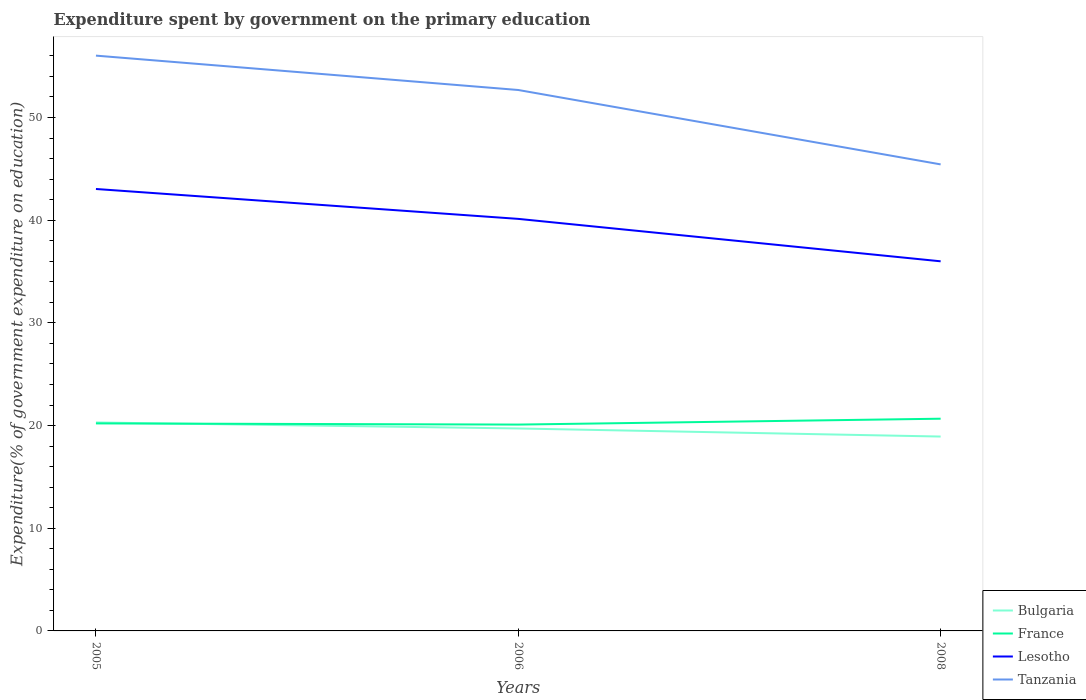Does the line corresponding to Lesotho intersect with the line corresponding to France?
Offer a terse response. No. Across all years, what is the maximum expenditure spent by government on the primary education in Tanzania?
Make the answer very short. 45.43. What is the total expenditure spent by government on the primary education in Lesotho in the graph?
Your answer should be very brief. 2.91. What is the difference between the highest and the second highest expenditure spent by government on the primary education in Tanzania?
Ensure brevity in your answer.  10.59. What is the difference between the highest and the lowest expenditure spent by government on the primary education in Tanzania?
Your response must be concise. 2. What is the difference between two consecutive major ticks on the Y-axis?
Keep it short and to the point. 10. Does the graph contain any zero values?
Provide a short and direct response. No. How many legend labels are there?
Offer a terse response. 4. What is the title of the graph?
Give a very brief answer. Expenditure spent by government on the primary education. Does "Japan" appear as one of the legend labels in the graph?
Your answer should be very brief. No. What is the label or title of the Y-axis?
Provide a succinct answer. Expenditure(% of government expenditure on education). What is the Expenditure(% of government expenditure on education) of Bulgaria in 2005?
Your answer should be very brief. 20.3. What is the Expenditure(% of government expenditure on education) of France in 2005?
Offer a very short reply. 20.21. What is the Expenditure(% of government expenditure on education) of Lesotho in 2005?
Make the answer very short. 43.04. What is the Expenditure(% of government expenditure on education) of Tanzania in 2005?
Make the answer very short. 56.02. What is the Expenditure(% of government expenditure on education) of Bulgaria in 2006?
Ensure brevity in your answer.  19.72. What is the Expenditure(% of government expenditure on education) in France in 2006?
Ensure brevity in your answer.  20.09. What is the Expenditure(% of government expenditure on education) in Lesotho in 2006?
Offer a very short reply. 40.12. What is the Expenditure(% of government expenditure on education) of Tanzania in 2006?
Your answer should be very brief. 52.68. What is the Expenditure(% of government expenditure on education) of Bulgaria in 2008?
Offer a very short reply. 18.93. What is the Expenditure(% of government expenditure on education) of France in 2008?
Give a very brief answer. 20.67. What is the Expenditure(% of government expenditure on education) of Lesotho in 2008?
Your answer should be compact. 35.99. What is the Expenditure(% of government expenditure on education) in Tanzania in 2008?
Your answer should be very brief. 45.43. Across all years, what is the maximum Expenditure(% of government expenditure on education) of Bulgaria?
Offer a very short reply. 20.3. Across all years, what is the maximum Expenditure(% of government expenditure on education) in France?
Offer a terse response. 20.67. Across all years, what is the maximum Expenditure(% of government expenditure on education) in Lesotho?
Your answer should be compact. 43.04. Across all years, what is the maximum Expenditure(% of government expenditure on education) of Tanzania?
Offer a very short reply. 56.02. Across all years, what is the minimum Expenditure(% of government expenditure on education) in Bulgaria?
Offer a very short reply. 18.93. Across all years, what is the minimum Expenditure(% of government expenditure on education) of France?
Your response must be concise. 20.09. Across all years, what is the minimum Expenditure(% of government expenditure on education) of Lesotho?
Give a very brief answer. 35.99. Across all years, what is the minimum Expenditure(% of government expenditure on education) in Tanzania?
Ensure brevity in your answer.  45.43. What is the total Expenditure(% of government expenditure on education) of Bulgaria in the graph?
Ensure brevity in your answer.  58.94. What is the total Expenditure(% of government expenditure on education) in France in the graph?
Provide a succinct answer. 60.97. What is the total Expenditure(% of government expenditure on education) in Lesotho in the graph?
Your response must be concise. 119.16. What is the total Expenditure(% of government expenditure on education) of Tanzania in the graph?
Provide a short and direct response. 154.13. What is the difference between the Expenditure(% of government expenditure on education) of Bulgaria in 2005 and that in 2006?
Give a very brief answer. 0.58. What is the difference between the Expenditure(% of government expenditure on education) of France in 2005 and that in 2006?
Provide a short and direct response. 0.11. What is the difference between the Expenditure(% of government expenditure on education) in Lesotho in 2005 and that in 2006?
Make the answer very short. 2.91. What is the difference between the Expenditure(% of government expenditure on education) of Tanzania in 2005 and that in 2006?
Provide a succinct answer. 3.35. What is the difference between the Expenditure(% of government expenditure on education) in Bulgaria in 2005 and that in 2008?
Give a very brief answer. 1.37. What is the difference between the Expenditure(% of government expenditure on education) in France in 2005 and that in 2008?
Provide a short and direct response. -0.46. What is the difference between the Expenditure(% of government expenditure on education) of Lesotho in 2005 and that in 2008?
Your answer should be very brief. 7.04. What is the difference between the Expenditure(% of government expenditure on education) of Tanzania in 2005 and that in 2008?
Offer a very short reply. 10.59. What is the difference between the Expenditure(% of government expenditure on education) of Bulgaria in 2006 and that in 2008?
Make the answer very short. 0.79. What is the difference between the Expenditure(% of government expenditure on education) of France in 2006 and that in 2008?
Give a very brief answer. -0.57. What is the difference between the Expenditure(% of government expenditure on education) in Lesotho in 2006 and that in 2008?
Provide a short and direct response. 4.13. What is the difference between the Expenditure(% of government expenditure on education) of Tanzania in 2006 and that in 2008?
Provide a succinct answer. 7.24. What is the difference between the Expenditure(% of government expenditure on education) in Bulgaria in 2005 and the Expenditure(% of government expenditure on education) in France in 2006?
Offer a very short reply. 0.21. What is the difference between the Expenditure(% of government expenditure on education) in Bulgaria in 2005 and the Expenditure(% of government expenditure on education) in Lesotho in 2006?
Keep it short and to the point. -19.82. What is the difference between the Expenditure(% of government expenditure on education) in Bulgaria in 2005 and the Expenditure(% of government expenditure on education) in Tanzania in 2006?
Provide a short and direct response. -32.38. What is the difference between the Expenditure(% of government expenditure on education) in France in 2005 and the Expenditure(% of government expenditure on education) in Lesotho in 2006?
Your answer should be compact. -19.92. What is the difference between the Expenditure(% of government expenditure on education) of France in 2005 and the Expenditure(% of government expenditure on education) of Tanzania in 2006?
Your answer should be compact. -32.47. What is the difference between the Expenditure(% of government expenditure on education) in Lesotho in 2005 and the Expenditure(% of government expenditure on education) in Tanzania in 2006?
Offer a terse response. -9.64. What is the difference between the Expenditure(% of government expenditure on education) in Bulgaria in 2005 and the Expenditure(% of government expenditure on education) in France in 2008?
Make the answer very short. -0.37. What is the difference between the Expenditure(% of government expenditure on education) of Bulgaria in 2005 and the Expenditure(% of government expenditure on education) of Lesotho in 2008?
Provide a succinct answer. -15.69. What is the difference between the Expenditure(% of government expenditure on education) in Bulgaria in 2005 and the Expenditure(% of government expenditure on education) in Tanzania in 2008?
Offer a very short reply. -25.13. What is the difference between the Expenditure(% of government expenditure on education) in France in 2005 and the Expenditure(% of government expenditure on education) in Lesotho in 2008?
Keep it short and to the point. -15.79. What is the difference between the Expenditure(% of government expenditure on education) in France in 2005 and the Expenditure(% of government expenditure on education) in Tanzania in 2008?
Offer a terse response. -25.22. What is the difference between the Expenditure(% of government expenditure on education) in Lesotho in 2005 and the Expenditure(% of government expenditure on education) in Tanzania in 2008?
Offer a very short reply. -2.4. What is the difference between the Expenditure(% of government expenditure on education) in Bulgaria in 2006 and the Expenditure(% of government expenditure on education) in France in 2008?
Offer a terse response. -0.95. What is the difference between the Expenditure(% of government expenditure on education) of Bulgaria in 2006 and the Expenditure(% of government expenditure on education) of Lesotho in 2008?
Keep it short and to the point. -16.28. What is the difference between the Expenditure(% of government expenditure on education) of Bulgaria in 2006 and the Expenditure(% of government expenditure on education) of Tanzania in 2008?
Your answer should be compact. -25.72. What is the difference between the Expenditure(% of government expenditure on education) of France in 2006 and the Expenditure(% of government expenditure on education) of Lesotho in 2008?
Offer a very short reply. -15.9. What is the difference between the Expenditure(% of government expenditure on education) in France in 2006 and the Expenditure(% of government expenditure on education) in Tanzania in 2008?
Make the answer very short. -25.34. What is the difference between the Expenditure(% of government expenditure on education) of Lesotho in 2006 and the Expenditure(% of government expenditure on education) of Tanzania in 2008?
Your response must be concise. -5.31. What is the average Expenditure(% of government expenditure on education) in Bulgaria per year?
Provide a short and direct response. 19.65. What is the average Expenditure(% of government expenditure on education) of France per year?
Give a very brief answer. 20.32. What is the average Expenditure(% of government expenditure on education) in Lesotho per year?
Make the answer very short. 39.72. What is the average Expenditure(% of government expenditure on education) of Tanzania per year?
Your answer should be very brief. 51.38. In the year 2005, what is the difference between the Expenditure(% of government expenditure on education) of Bulgaria and Expenditure(% of government expenditure on education) of France?
Offer a very short reply. 0.09. In the year 2005, what is the difference between the Expenditure(% of government expenditure on education) in Bulgaria and Expenditure(% of government expenditure on education) in Lesotho?
Ensure brevity in your answer.  -22.74. In the year 2005, what is the difference between the Expenditure(% of government expenditure on education) of Bulgaria and Expenditure(% of government expenditure on education) of Tanzania?
Your response must be concise. -35.72. In the year 2005, what is the difference between the Expenditure(% of government expenditure on education) of France and Expenditure(% of government expenditure on education) of Lesotho?
Provide a short and direct response. -22.83. In the year 2005, what is the difference between the Expenditure(% of government expenditure on education) in France and Expenditure(% of government expenditure on education) in Tanzania?
Your answer should be very brief. -35.82. In the year 2005, what is the difference between the Expenditure(% of government expenditure on education) of Lesotho and Expenditure(% of government expenditure on education) of Tanzania?
Your response must be concise. -12.99. In the year 2006, what is the difference between the Expenditure(% of government expenditure on education) of Bulgaria and Expenditure(% of government expenditure on education) of France?
Keep it short and to the point. -0.38. In the year 2006, what is the difference between the Expenditure(% of government expenditure on education) of Bulgaria and Expenditure(% of government expenditure on education) of Lesotho?
Offer a very short reply. -20.41. In the year 2006, what is the difference between the Expenditure(% of government expenditure on education) in Bulgaria and Expenditure(% of government expenditure on education) in Tanzania?
Your answer should be very brief. -32.96. In the year 2006, what is the difference between the Expenditure(% of government expenditure on education) in France and Expenditure(% of government expenditure on education) in Lesotho?
Give a very brief answer. -20.03. In the year 2006, what is the difference between the Expenditure(% of government expenditure on education) in France and Expenditure(% of government expenditure on education) in Tanzania?
Ensure brevity in your answer.  -32.58. In the year 2006, what is the difference between the Expenditure(% of government expenditure on education) of Lesotho and Expenditure(% of government expenditure on education) of Tanzania?
Offer a very short reply. -12.55. In the year 2008, what is the difference between the Expenditure(% of government expenditure on education) of Bulgaria and Expenditure(% of government expenditure on education) of France?
Give a very brief answer. -1.74. In the year 2008, what is the difference between the Expenditure(% of government expenditure on education) of Bulgaria and Expenditure(% of government expenditure on education) of Lesotho?
Offer a very short reply. -17.07. In the year 2008, what is the difference between the Expenditure(% of government expenditure on education) of Bulgaria and Expenditure(% of government expenditure on education) of Tanzania?
Offer a terse response. -26.5. In the year 2008, what is the difference between the Expenditure(% of government expenditure on education) in France and Expenditure(% of government expenditure on education) in Lesotho?
Ensure brevity in your answer.  -15.33. In the year 2008, what is the difference between the Expenditure(% of government expenditure on education) of France and Expenditure(% of government expenditure on education) of Tanzania?
Give a very brief answer. -24.77. In the year 2008, what is the difference between the Expenditure(% of government expenditure on education) in Lesotho and Expenditure(% of government expenditure on education) in Tanzania?
Your response must be concise. -9.44. What is the ratio of the Expenditure(% of government expenditure on education) of Bulgaria in 2005 to that in 2006?
Provide a succinct answer. 1.03. What is the ratio of the Expenditure(% of government expenditure on education) of France in 2005 to that in 2006?
Ensure brevity in your answer.  1.01. What is the ratio of the Expenditure(% of government expenditure on education) of Lesotho in 2005 to that in 2006?
Offer a very short reply. 1.07. What is the ratio of the Expenditure(% of government expenditure on education) in Tanzania in 2005 to that in 2006?
Provide a short and direct response. 1.06. What is the ratio of the Expenditure(% of government expenditure on education) of Bulgaria in 2005 to that in 2008?
Your answer should be compact. 1.07. What is the ratio of the Expenditure(% of government expenditure on education) in France in 2005 to that in 2008?
Your answer should be very brief. 0.98. What is the ratio of the Expenditure(% of government expenditure on education) of Lesotho in 2005 to that in 2008?
Your answer should be very brief. 1.2. What is the ratio of the Expenditure(% of government expenditure on education) of Tanzania in 2005 to that in 2008?
Provide a short and direct response. 1.23. What is the ratio of the Expenditure(% of government expenditure on education) of Bulgaria in 2006 to that in 2008?
Your answer should be compact. 1.04. What is the ratio of the Expenditure(% of government expenditure on education) in France in 2006 to that in 2008?
Your response must be concise. 0.97. What is the ratio of the Expenditure(% of government expenditure on education) of Lesotho in 2006 to that in 2008?
Make the answer very short. 1.11. What is the ratio of the Expenditure(% of government expenditure on education) of Tanzania in 2006 to that in 2008?
Keep it short and to the point. 1.16. What is the difference between the highest and the second highest Expenditure(% of government expenditure on education) of Bulgaria?
Offer a terse response. 0.58. What is the difference between the highest and the second highest Expenditure(% of government expenditure on education) in France?
Your answer should be compact. 0.46. What is the difference between the highest and the second highest Expenditure(% of government expenditure on education) in Lesotho?
Ensure brevity in your answer.  2.91. What is the difference between the highest and the second highest Expenditure(% of government expenditure on education) of Tanzania?
Offer a very short reply. 3.35. What is the difference between the highest and the lowest Expenditure(% of government expenditure on education) of Bulgaria?
Provide a short and direct response. 1.37. What is the difference between the highest and the lowest Expenditure(% of government expenditure on education) of France?
Your answer should be compact. 0.57. What is the difference between the highest and the lowest Expenditure(% of government expenditure on education) in Lesotho?
Make the answer very short. 7.04. What is the difference between the highest and the lowest Expenditure(% of government expenditure on education) of Tanzania?
Make the answer very short. 10.59. 